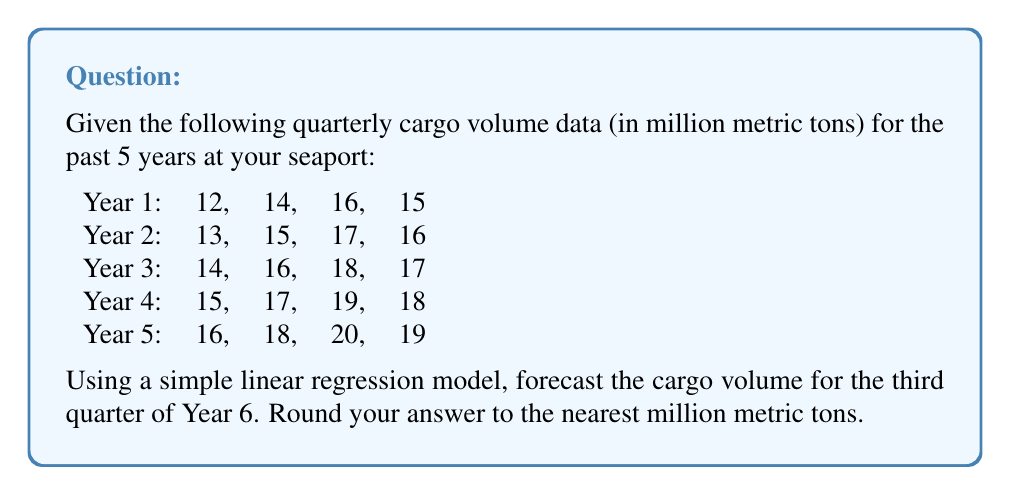Help me with this question. To forecast the cargo volume using a simple linear regression model, we'll follow these steps:

1) First, we need to assign time values to our data points. Let's use t = 1 for the first quarter of Year 1, t = 2 for the second quarter, and so on. The third quarter of Year 6 would be t = 23.

2) Now we have 20 data points (t, y) where t is the time period and y is the cargo volume.

3) We'll use the linear regression formula:

   $$y = \beta_0 + \beta_1t$$

   where $\beta_0$ is the y-intercept and $\beta_1$ is the slope.

4) To calculate $\beta_0$ and $\beta_1$, we use these formulas:

   $$\beta_1 = \frac{n\sum(ty) - \sum t \sum y}{n\sum t^2 - (\sum t)^2}$$

   $$\beta_0 = \bar{y} - \beta_1\bar{t}$$

   where n is the number of data points, $\bar{y}$ is the mean of y values, and $\bar{t}$ is the mean of t values.

5) Calculating the sums:
   $n = 20$
   $\sum t = 210$
   $\sum y = 325$
   $\sum t^2 = 3010$
   $\sum ty = 3655$

6) Plugging into the formula for $\beta_1$:

   $$\beta_1 = \frac{20(3655) - 210(325)}{20(3010) - 210^2} = 0.2$$

7) Calculating means:
   $\bar{t} = 210/20 = 10.5$
   $\bar{y} = 325/20 = 16.25$

8) Calculating $\beta_0$:

   $$\beta_0 = 16.25 - 0.2(10.5) = 14.15$$

9) Our regression equation is thus:

   $$y = 14.15 + 0.2t$$

10) For the third quarter of Year 6, t = 23. Plugging this into our equation:

    $$y = 14.15 + 0.2(23) = 18.75$$

11) Rounding to the nearest million metric tons gives us 19.
Answer: 19 million metric tons 